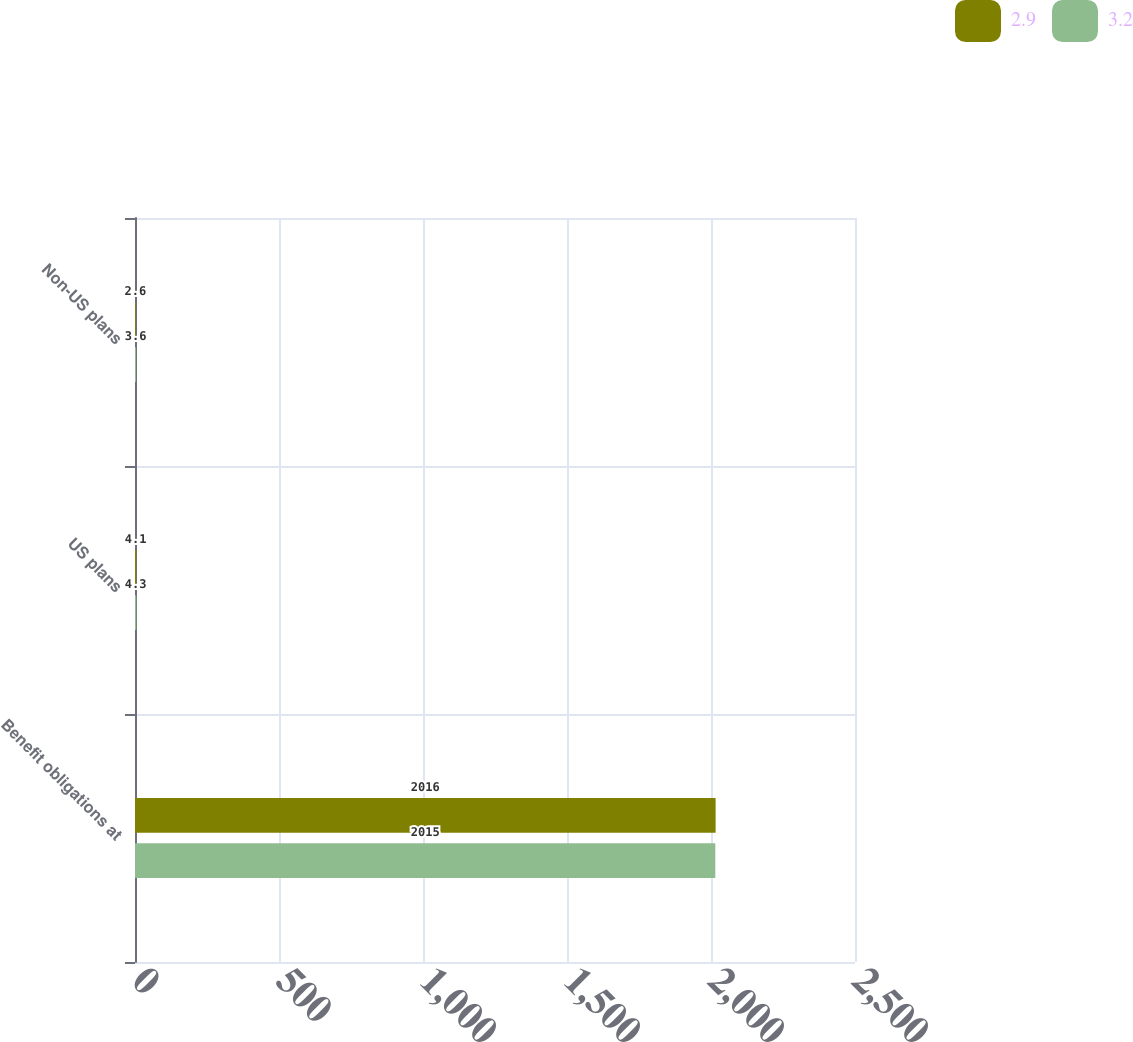Convert chart. <chart><loc_0><loc_0><loc_500><loc_500><stacked_bar_chart><ecel><fcel>Benefit obligations at<fcel>US plans<fcel>Non-US plans<nl><fcel>2.9<fcel>2016<fcel>4.1<fcel>2.6<nl><fcel>3.2<fcel>2015<fcel>4.3<fcel>3.6<nl></chart> 